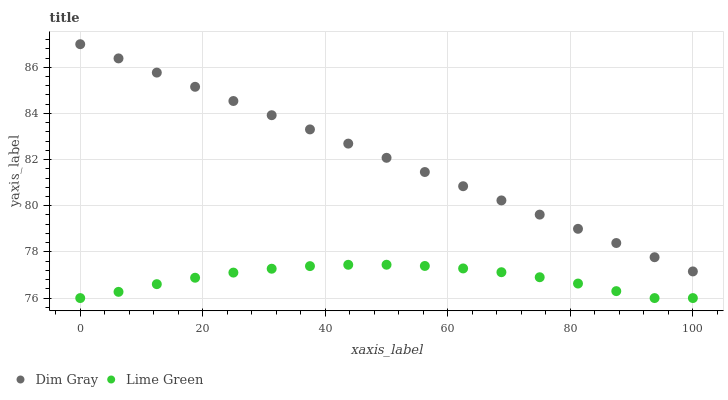Does Lime Green have the minimum area under the curve?
Answer yes or no. Yes. Does Dim Gray have the maximum area under the curve?
Answer yes or no. Yes. Does Lime Green have the maximum area under the curve?
Answer yes or no. No. Is Dim Gray the smoothest?
Answer yes or no. Yes. Is Lime Green the roughest?
Answer yes or no. Yes. Is Lime Green the smoothest?
Answer yes or no. No. Does Lime Green have the lowest value?
Answer yes or no. Yes. Does Dim Gray have the highest value?
Answer yes or no. Yes. Does Lime Green have the highest value?
Answer yes or no. No. Is Lime Green less than Dim Gray?
Answer yes or no. Yes. Is Dim Gray greater than Lime Green?
Answer yes or no. Yes. Does Lime Green intersect Dim Gray?
Answer yes or no. No. 